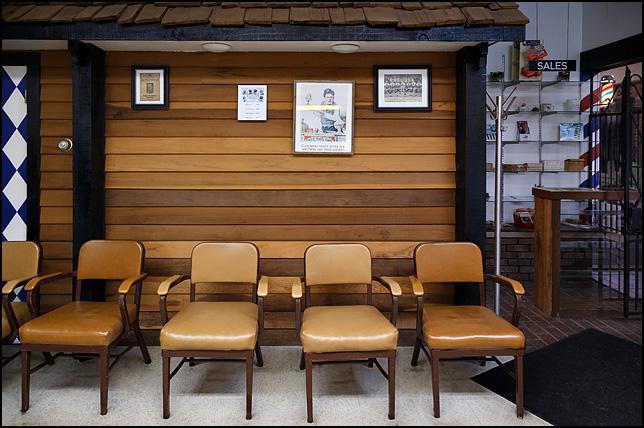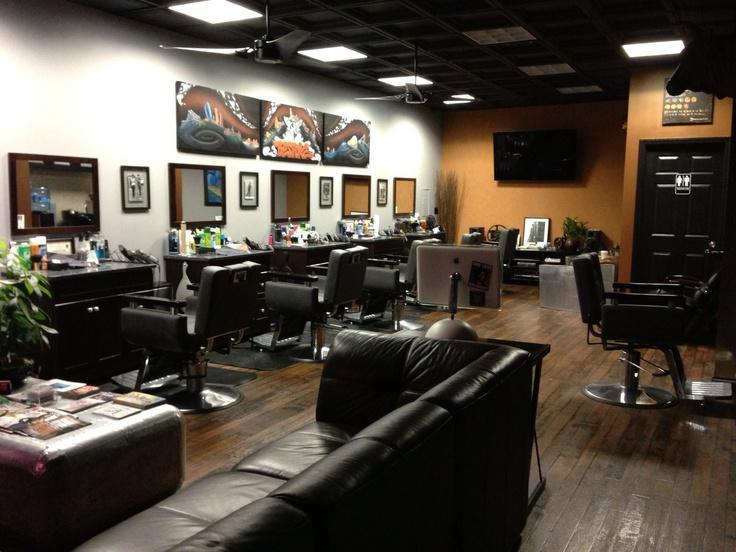The first image is the image on the left, the second image is the image on the right. Assess this claim about the two images: "In one of the image there is at least one man sitting down on a couch.". Correct or not? Answer yes or no. No. 